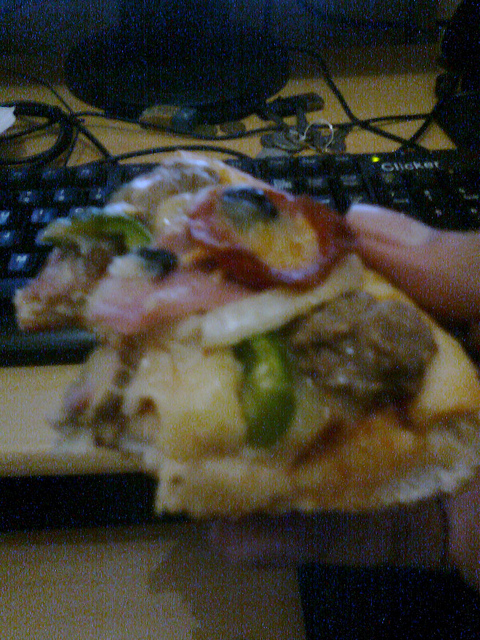Has someone eaten the pizza? Yes, the slice shown has been partially eaten. 